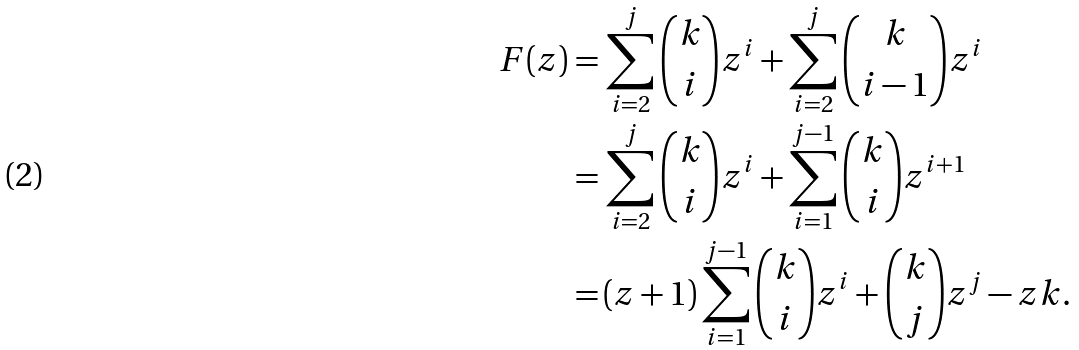Convert formula to latex. <formula><loc_0><loc_0><loc_500><loc_500>F ( z ) = \, & \sum _ { i = 2 } ^ { j } \binom { k } { i } z ^ { i } + \sum _ { i = 2 } ^ { j } \binom { k } { i - 1 } z ^ { i } \\ = \, & \sum _ { i = 2 } ^ { j } \binom { k } { i } z ^ { i } + \sum _ { i = 1 } ^ { j - 1 } \binom { k } { i } z ^ { i + 1 } \\ = \, & ( z + 1 ) \sum _ { i = 1 } ^ { j - 1 } \binom { k } { i } z ^ { i } + \binom { k } { j } z ^ { j } - z k . \\</formula> 